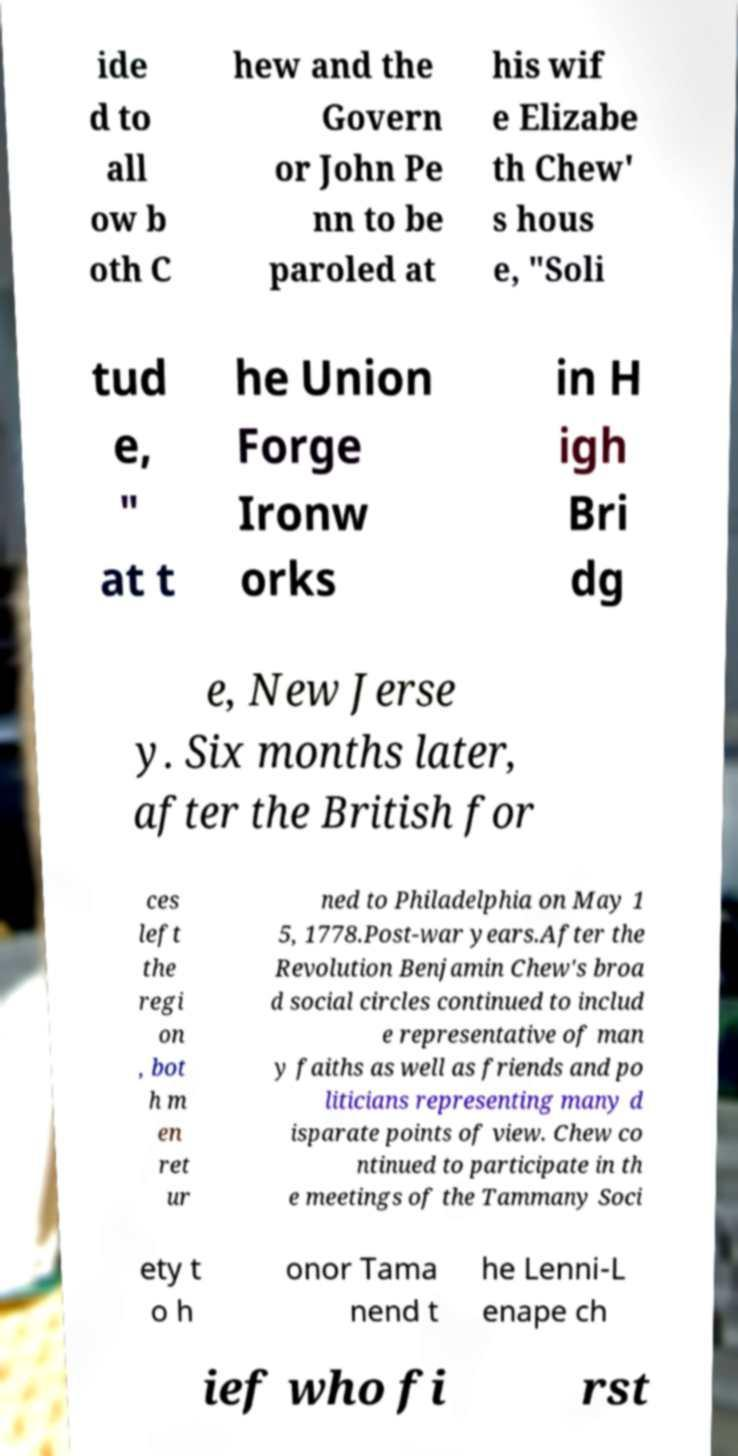There's text embedded in this image that I need extracted. Can you transcribe it verbatim? ide d to all ow b oth C hew and the Govern or John Pe nn to be paroled at his wif e Elizabe th Chew' s hous e, "Soli tud e, " at t he Union Forge Ironw orks in H igh Bri dg e, New Jerse y. Six months later, after the British for ces left the regi on , bot h m en ret ur ned to Philadelphia on May 1 5, 1778.Post-war years.After the Revolution Benjamin Chew's broa d social circles continued to includ e representative of man y faiths as well as friends and po liticians representing many d isparate points of view. Chew co ntinued to participate in th e meetings of the Tammany Soci ety t o h onor Tama nend t he Lenni-L enape ch ief who fi rst 